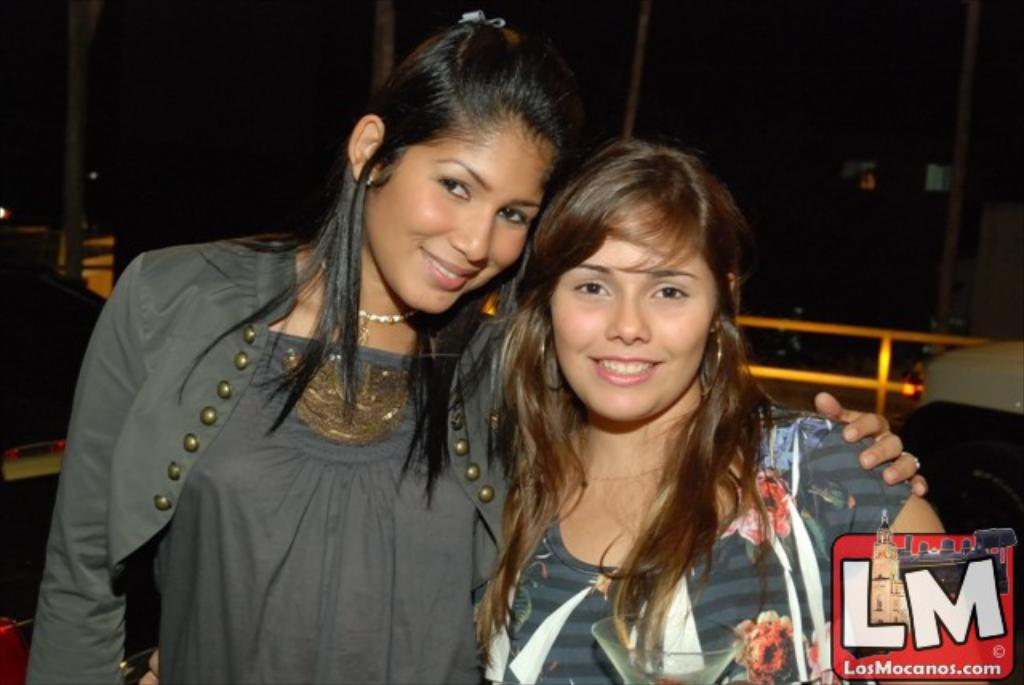How many people are in the image? There are two persons in the image. What is the facial expression of the persons in the image? The persons are smiling. What can be seen in the background of the image? Vehicles, iron rods, and poles are visible in the background of the image. Is there any indication of the image's origin or ownership? Yes, there is a watermark on the image. What type of disease is being treated by the oven in the image? There is no oven present in the image, and therefore no disease treatment can be observed. What is the purpose of the image? The purpose of the image cannot be determined from the provided facts; it may be for personal or professional use. 